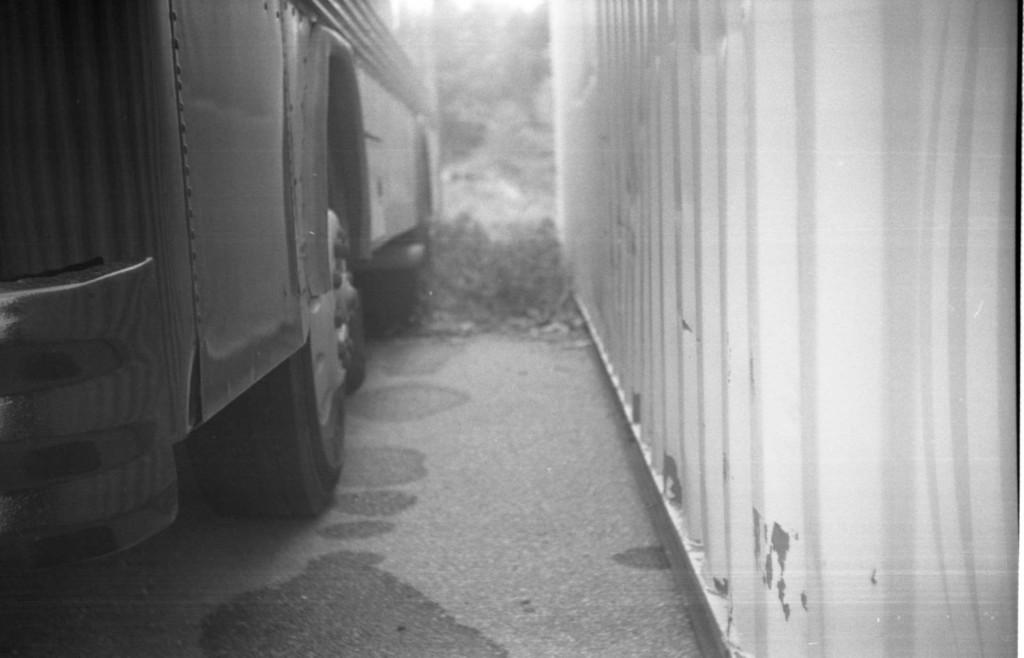What type of picture is in the image? The image contains a black and white picture. What is the main subject of the black and white picture? There is a vehicle in the black and white picture. Where is the vehicle located in the picture? The vehicle is on the ground in the picture. What color is the object in the black and white picture? The object is white in color. What can be seen in the background of the black and white picture? There are trees visible in the background of the black and white picture. How many spiders are crawling on the clock in the image? There is no clock or spiders present in the image. What type of impulse is being displayed by the vehicle in the image? The image is black and white, so it is not possible to determine any impulses or emotions displayed by the vehicle. 